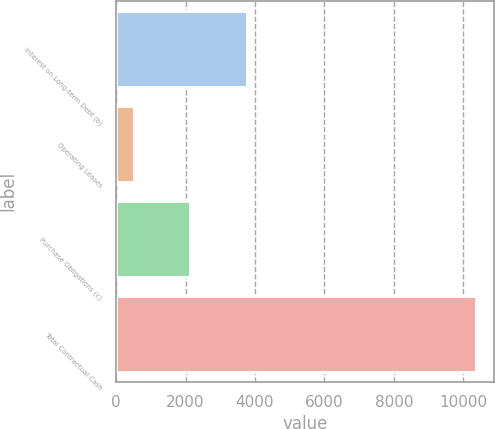Convert chart. <chart><loc_0><loc_0><loc_500><loc_500><bar_chart><fcel>Interest on Long-term Debt (b)<fcel>Operating Leases<fcel>Purchase Obligations (c)<fcel>Total Contractual Cash<nl><fcel>3777<fcel>528<fcel>2141<fcel>10365<nl></chart> 